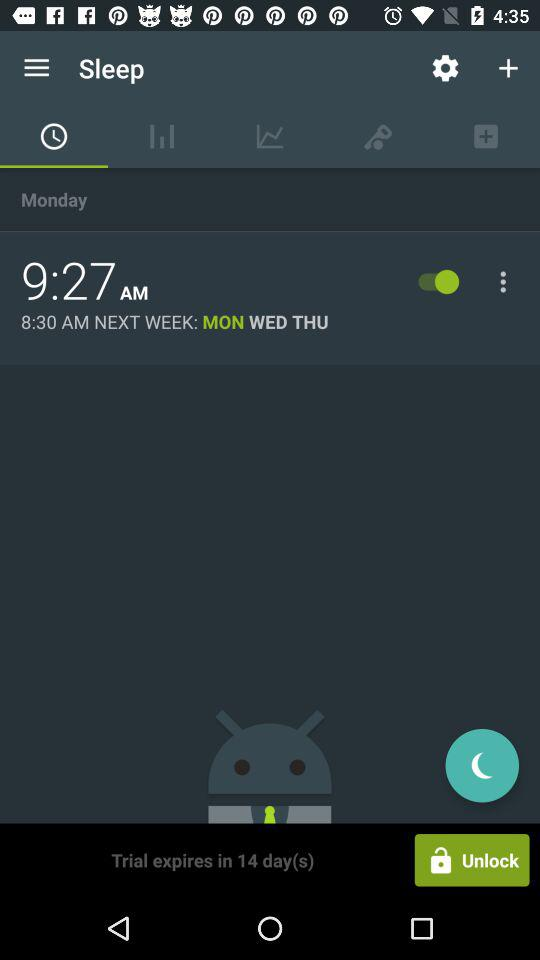Which tab is currently selected? The currently selected tab is "Alarm". 